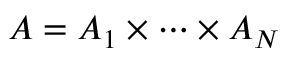Convert formula to latex. <formula><loc_0><loc_0><loc_500><loc_500>A = A _ { 1 } \times \cdots \times A _ { N }</formula> 